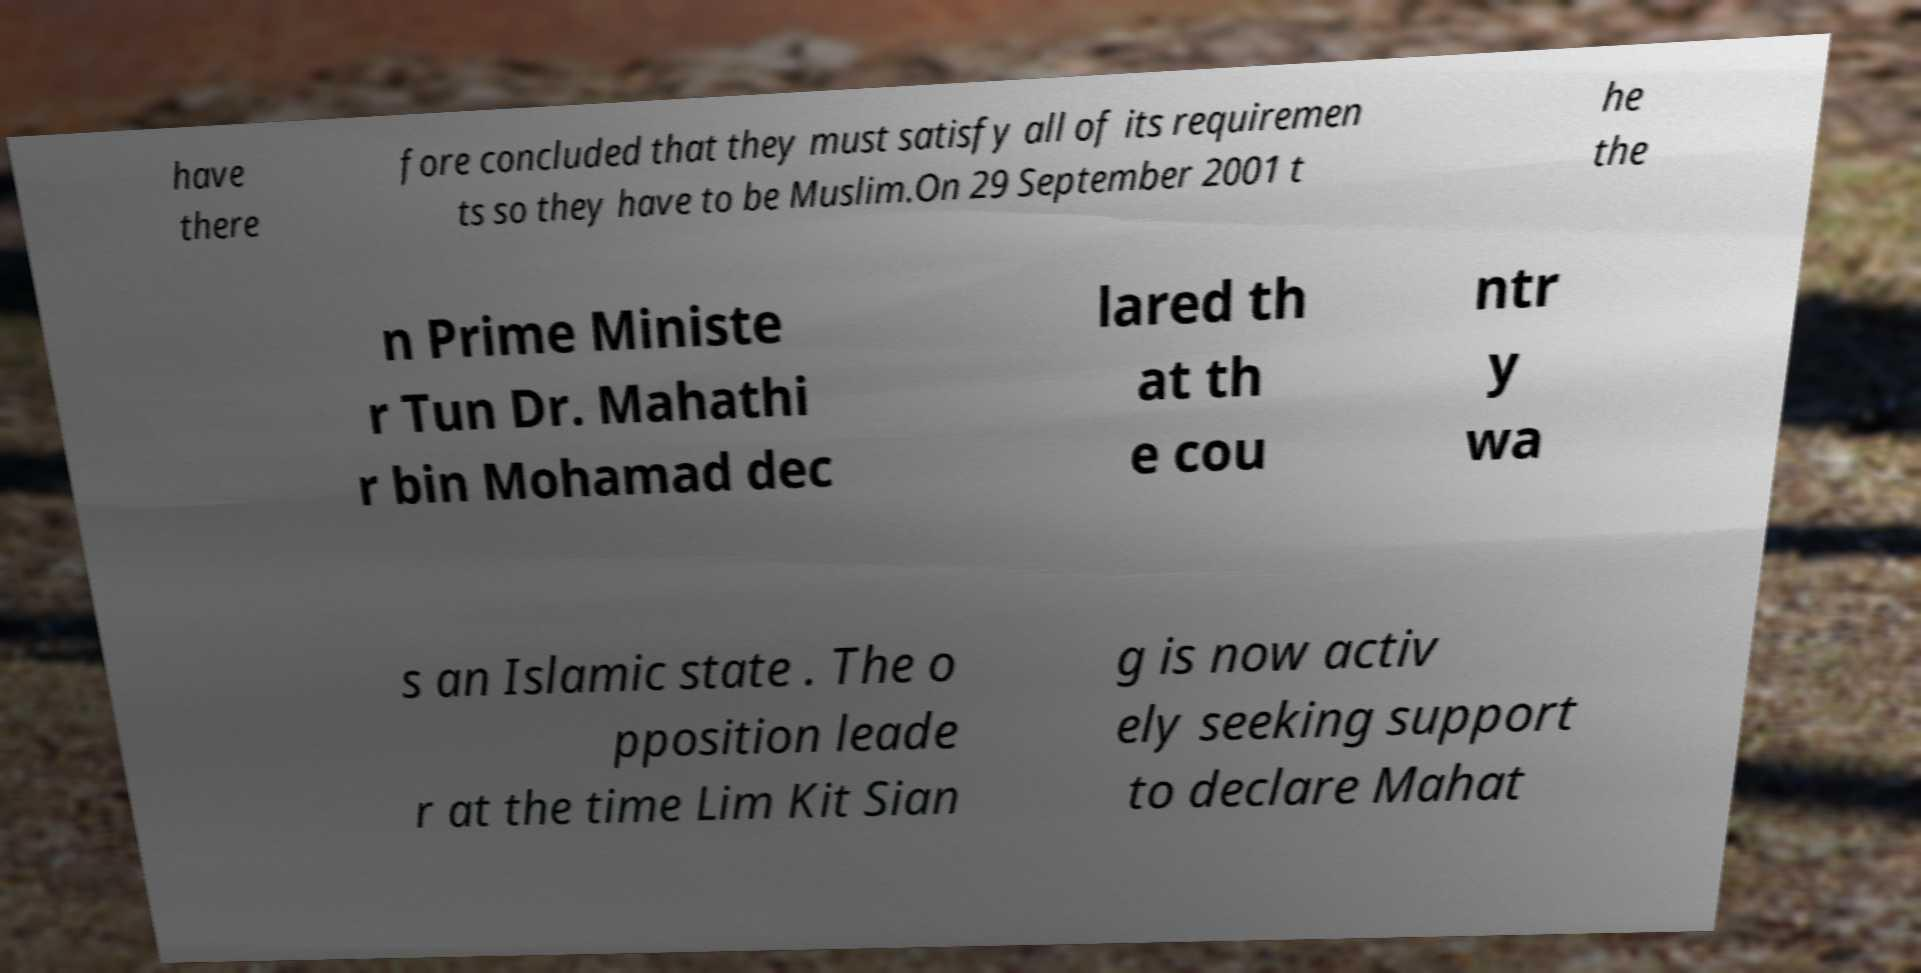Could you assist in decoding the text presented in this image and type it out clearly? have there fore concluded that they must satisfy all of its requiremen ts so they have to be Muslim.On 29 September 2001 t he the n Prime Ministe r Tun Dr. Mahathi r bin Mohamad dec lared th at th e cou ntr y wa s an Islamic state . The o pposition leade r at the time Lim Kit Sian g is now activ ely seeking support to declare Mahat 